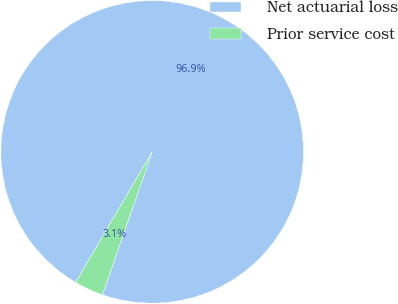Convert chart to OTSL. <chart><loc_0><loc_0><loc_500><loc_500><pie_chart><fcel>Net actuarial loss<fcel>Prior service cost<nl><fcel>96.9%<fcel>3.1%<nl></chart> 